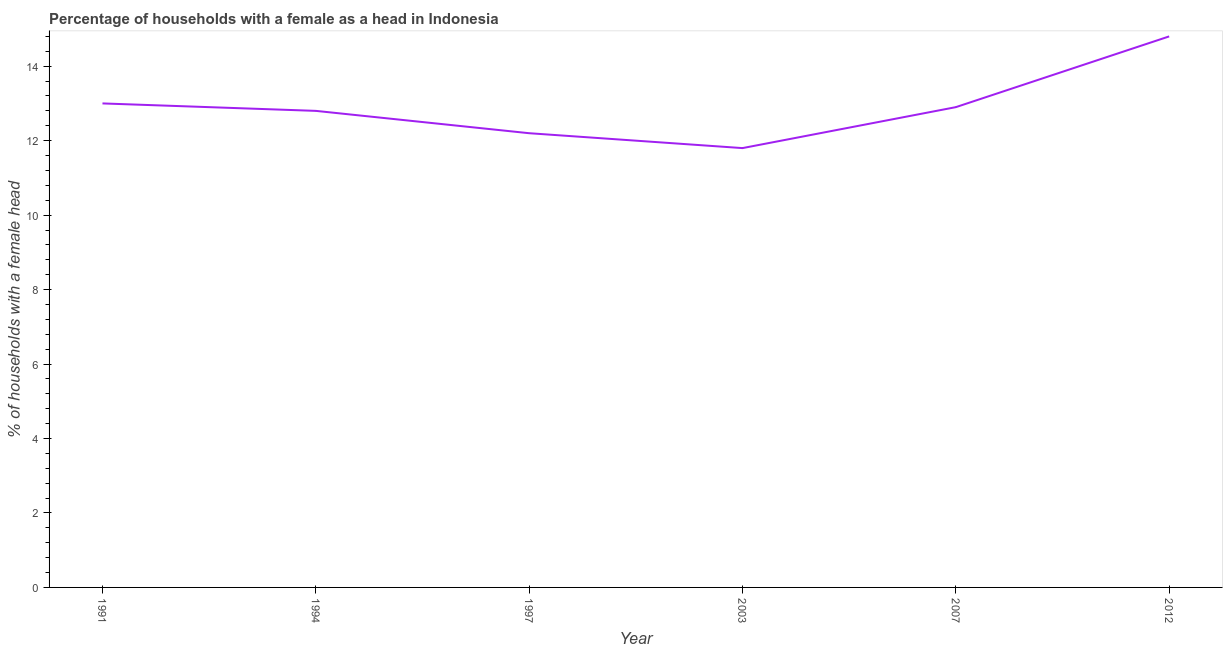Across all years, what is the maximum number of female supervised households?
Provide a short and direct response. 14.8. In which year was the number of female supervised households maximum?
Provide a succinct answer. 2012. In which year was the number of female supervised households minimum?
Offer a very short reply. 2003. What is the sum of the number of female supervised households?
Provide a short and direct response. 77.5. What is the difference between the number of female supervised households in 1994 and 1997?
Keep it short and to the point. 0.6. What is the average number of female supervised households per year?
Provide a succinct answer. 12.92. What is the median number of female supervised households?
Your response must be concise. 12.85. What is the ratio of the number of female supervised households in 1997 to that in 2003?
Your answer should be very brief. 1.03. Is the number of female supervised households in 2007 less than that in 2012?
Your answer should be compact. Yes. Is the difference between the number of female supervised households in 1997 and 2003 greater than the difference between any two years?
Offer a very short reply. No. What is the difference between the highest and the second highest number of female supervised households?
Offer a terse response. 1.8. Is the sum of the number of female supervised households in 1994 and 1997 greater than the maximum number of female supervised households across all years?
Provide a short and direct response. Yes. What is the difference between the highest and the lowest number of female supervised households?
Give a very brief answer. 3. Does the number of female supervised households monotonically increase over the years?
Keep it short and to the point. No. How many lines are there?
Keep it short and to the point. 1. What is the difference between two consecutive major ticks on the Y-axis?
Ensure brevity in your answer.  2. Are the values on the major ticks of Y-axis written in scientific E-notation?
Give a very brief answer. No. What is the title of the graph?
Offer a terse response. Percentage of households with a female as a head in Indonesia. What is the label or title of the X-axis?
Your answer should be very brief. Year. What is the label or title of the Y-axis?
Provide a short and direct response. % of households with a female head. What is the % of households with a female head of 1994?
Provide a short and direct response. 12.8. What is the % of households with a female head of 1997?
Provide a succinct answer. 12.2. What is the % of households with a female head of 2007?
Make the answer very short. 12.9. What is the difference between the % of households with a female head in 1994 and 1997?
Provide a short and direct response. 0.6. What is the difference between the % of households with a female head in 1994 and 2003?
Make the answer very short. 1. What is the difference between the % of households with a female head in 1994 and 2012?
Your answer should be very brief. -2. What is the difference between the % of households with a female head in 1997 and 2007?
Provide a short and direct response. -0.7. What is the difference between the % of households with a female head in 1997 and 2012?
Keep it short and to the point. -2.6. What is the difference between the % of households with a female head in 2007 and 2012?
Provide a short and direct response. -1.9. What is the ratio of the % of households with a female head in 1991 to that in 1997?
Give a very brief answer. 1.07. What is the ratio of the % of households with a female head in 1991 to that in 2003?
Your response must be concise. 1.1. What is the ratio of the % of households with a female head in 1991 to that in 2007?
Provide a short and direct response. 1.01. What is the ratio of the % of households with a female head in 1991 to that in 2012?
Provide a short and direct response. 0.88. What is the ratio of the % of households with a female head in 1994 to that in 1997?
Offer a terse response. 1.05. What is the ratio of the % of households with a female head in 1994 to that in 2003?
Keep it short and to the point. 1.08. What is the ratio of the % of households with a female head in 1994 to that in 2007?
Provide a short and direct response. 0.99. What is the ratio of the % of households with a female head in 1994 to that in 2012?
Provide a succinct answer. 0.86. What is the ratio of the % of households with a female head in 1997 to that in 2003?
Your answer should be very brief. 1.03. What is the ratio of the % of households with a female head in 1997 to that in 2007?
Your response must be concise. 0.95. What is the ratio of the % of households with a female head in 1997 to that in 2012?
Your response must be concise. 0.82. What is the ratio of the % of households with a female head in 2003 to that in 2007?
Your response must be concise. 0.92. What is the ratio of the % of households with a female head in 2003 to that in 2012?
Offer a terse response. 0.8. What is the ratio of the % of households with a female head in 2007 to that in 2012?
Give a very brief answer. 0.87. 